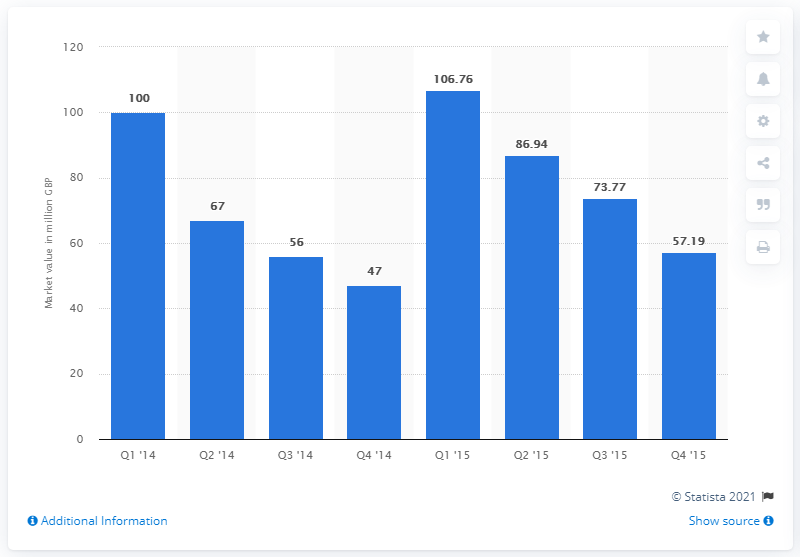Point out several critical features in this image. The invoice trading market had a value of $100 billion in the fourth quarter of 2014. In the fourth quarter of 2015, the value of invoice trading in the market was 106.76.... 